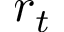Convert formula to latex. <formula><loc_0><loc_0><loc_500><loc_500>r _ { t }</formula> 